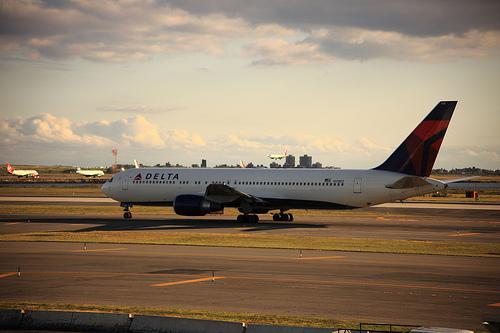Question: what is in the photo?
Choices:
A. A kite.
B. A hot air balloon.
C. A blimp.
D. A plane.
Answer with the letter. Answer: D Question: where is the plane?
Choices:
A. In the air.
B. And a hanger.
C. Behind the clouds.
D. On the landing strip.
Answer with the letter. Answer: D Question: what does the plane say?
Choices:
A. Delta.
B. Southwest.
C. American Airlines.
D. Allegiant.
Answer with the letter. Answer: A Question: who is in the photo?
Choices:
A. Cheerleaders.
B. Firemen.
C. Police officers.
D. No one.
Answer with the letter. Answer: D Question: when was the photo taken?
Choices:
A. Night.
B. Dinner.
C. Evening.
D. Sunset.
Answer with the letter. Answer: C 